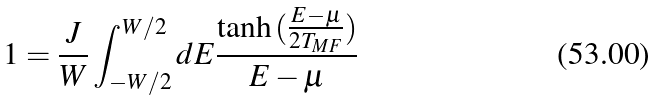<formula> <loc_0><loc_0><loc_500><loc_500>1 = \frac { J } { W } \int _ { - W / 2 } ^ { W / 2 } d E \frac { \tanh { ( \frac { E - \mu } { 2 T _ { M F } } } ) } { E - \mu }</formula> 